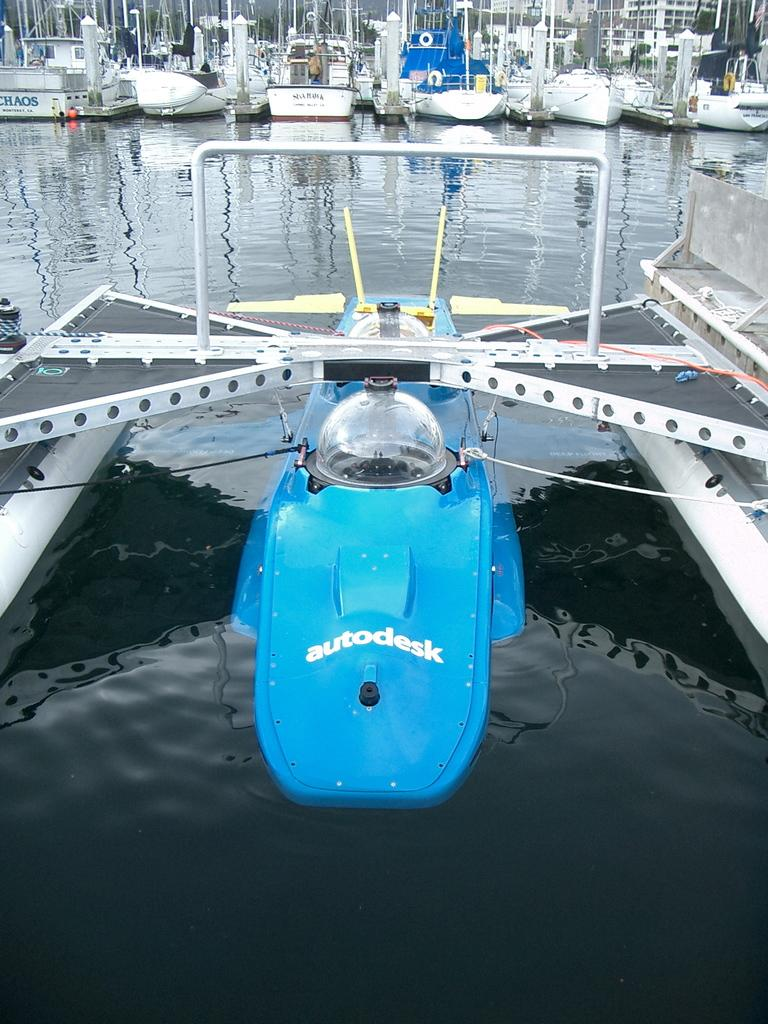<image>
Provide a brief description of the given image. an autodesk word at the bottom of a boat 